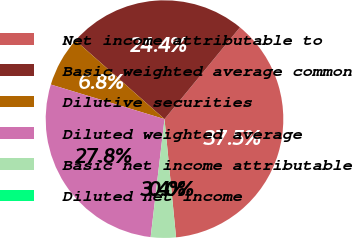<chart> <loc_0><loc_0><loc_500><loc_500><pie_chart><fcel>Net income attributable to<fcel>Basic weighted average common<fcel>Dilutive securities<fcel>Diluted weighted average<fcel>Basic net income attributable<fcel>Diluted net income<nl><fcel>37.5%<fcel>24.43%<fcel>6.82%<fcel>27.84%<fcel>3.41%<fcel>0.0%<nl></chart> 